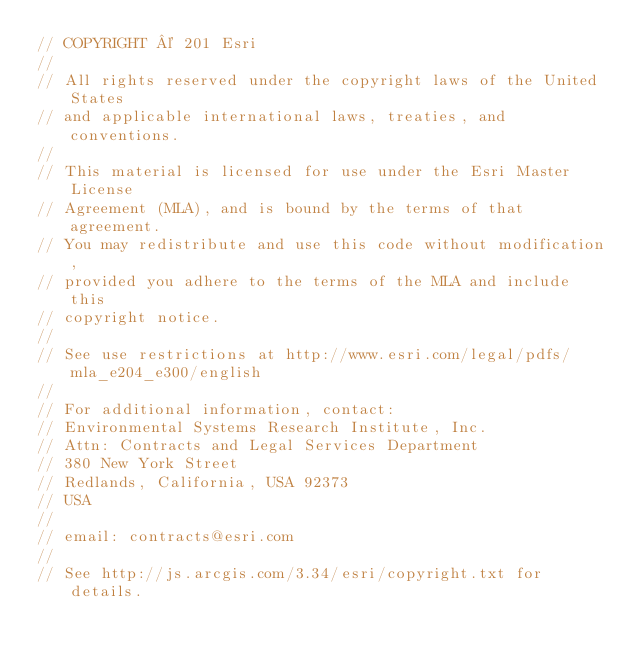<code> <loc_0><loc_0><loc_500><loc_500><_JavaScript_>// COPYRIGHT © 201 Esri
//
// All rights reserved under the copyright laws of the United States
// and applicable international laws, treaties, and conventions.
//
// This material is licensed for use under the Esri Master License
// Agreement (MLA), and is bound by the terms of that agreement.
// You may redistribute and use this code without modification,
// provided you adhere to the terms of the MLA and include this
// copyright notice.
//
// See use restrictions at http://www.esri.com/legal/pdfs/mla_e204_e300/english
//
// For additional information, contact:
// Environmental Systems Research Institute, Inc.
// Attn: Contracts and Legal Services Department
// 380 New York Street
// Redlands, California, USA 92373
// USA
//
// email: contracts@esri.com
//
// See http://js.arcgis.com/3.34/esri/copyright.txt for details.
</code> 